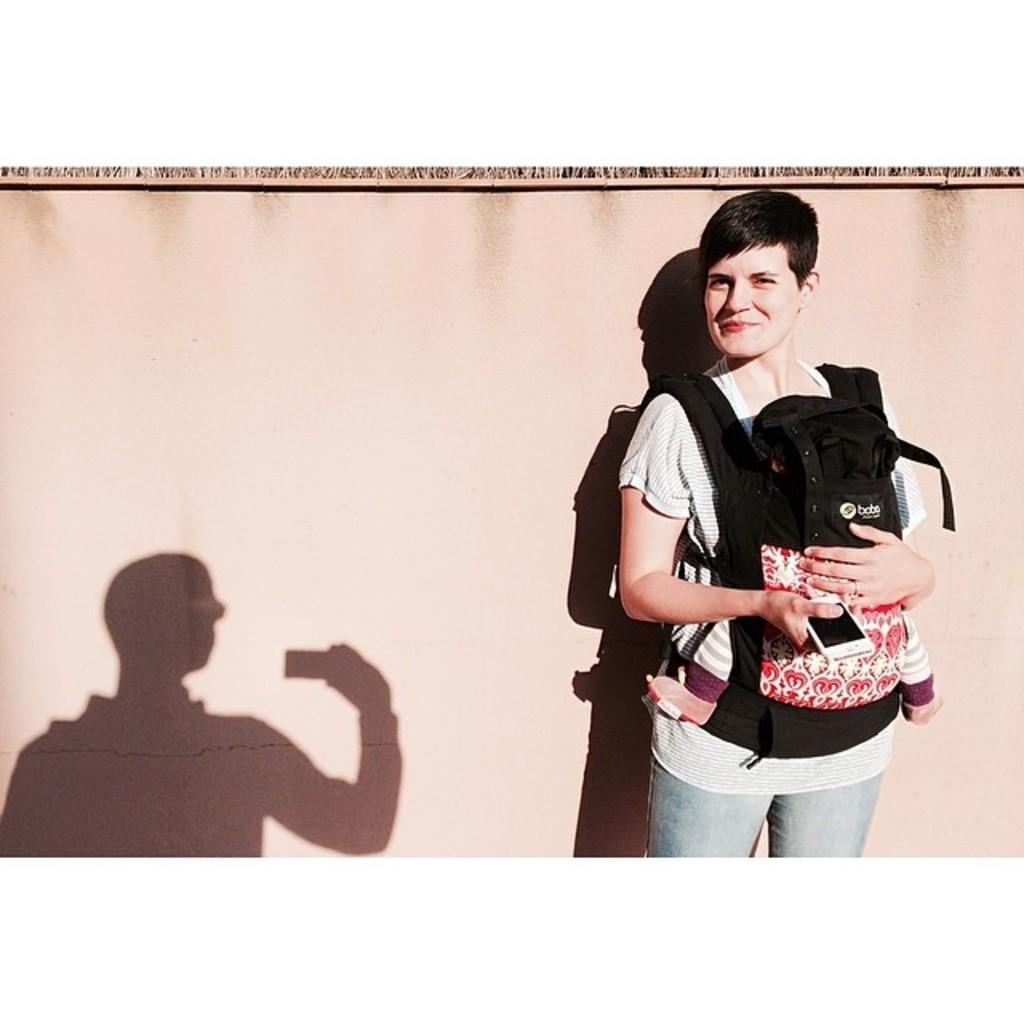What is the person on the right side of the image doing? The person on the right side of the image is holding a baby. Where is the shadow of the person located in the image? The shadow of the person is on the left side of the image. What color can be seen in the background of the image? There is a brown color in the background of the image. What type of animal is wearing a sweater in the image? There is no animal wearing a sweater present in the image. What is the source of shade in the image? There is no shade present in the image; it is a well-lit scene. 